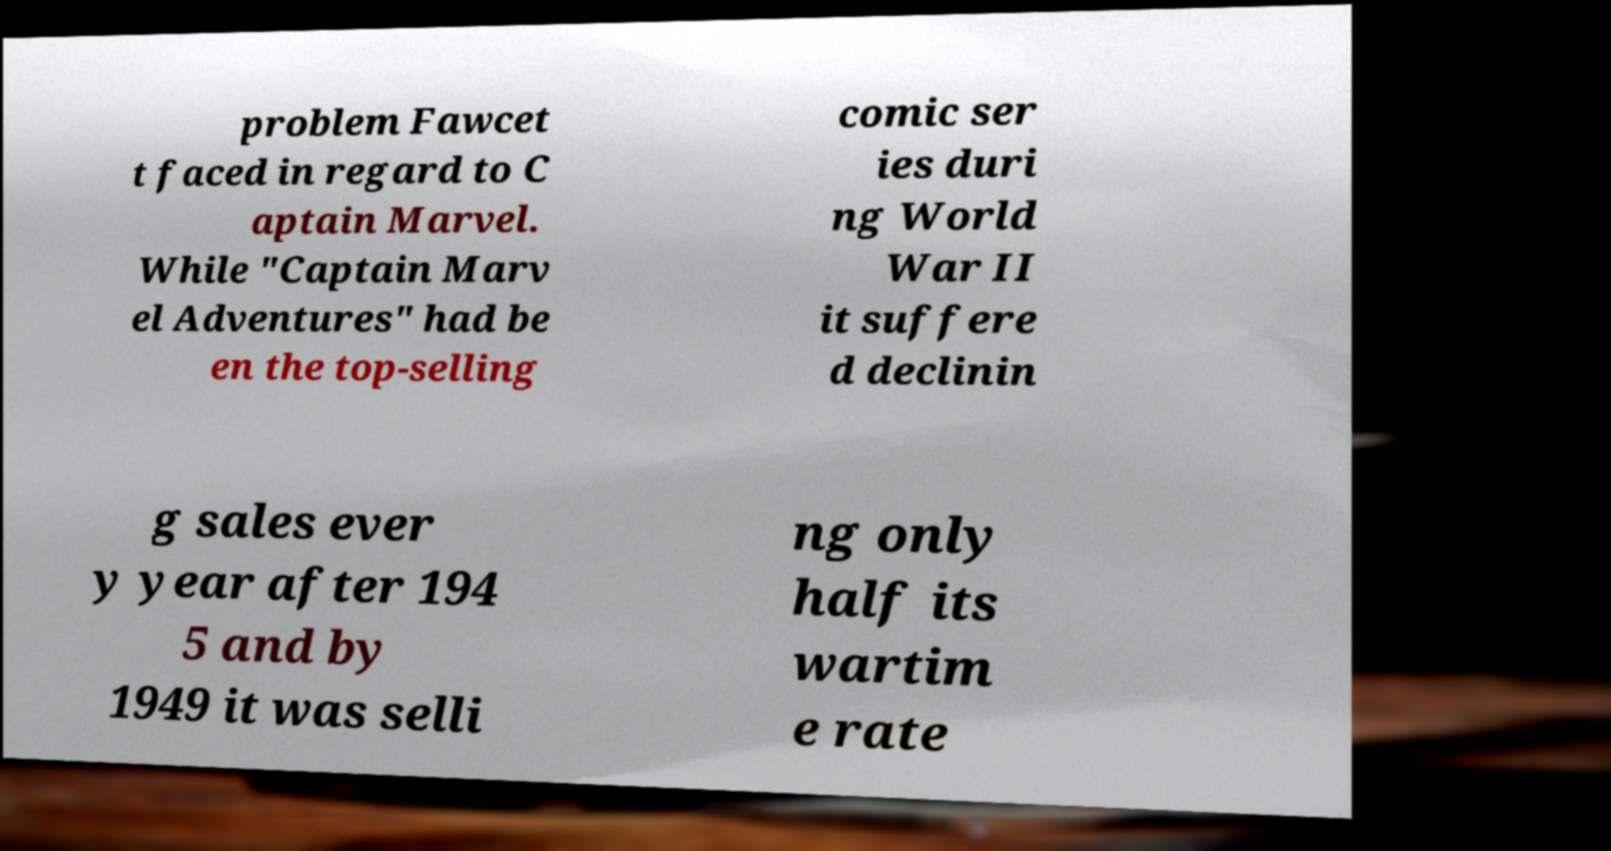I need the written content from this picture converted into text. Can you do that? problem Fawcet t faced in regard to C aptain Marvel. While "Captain Marv el Adventures" had be en the top-selling comic ser ies duri ng World War II it suffere d declinin g sales ever y year after 194 5 and by 1949 it was selli ng only half its wartim e rate 